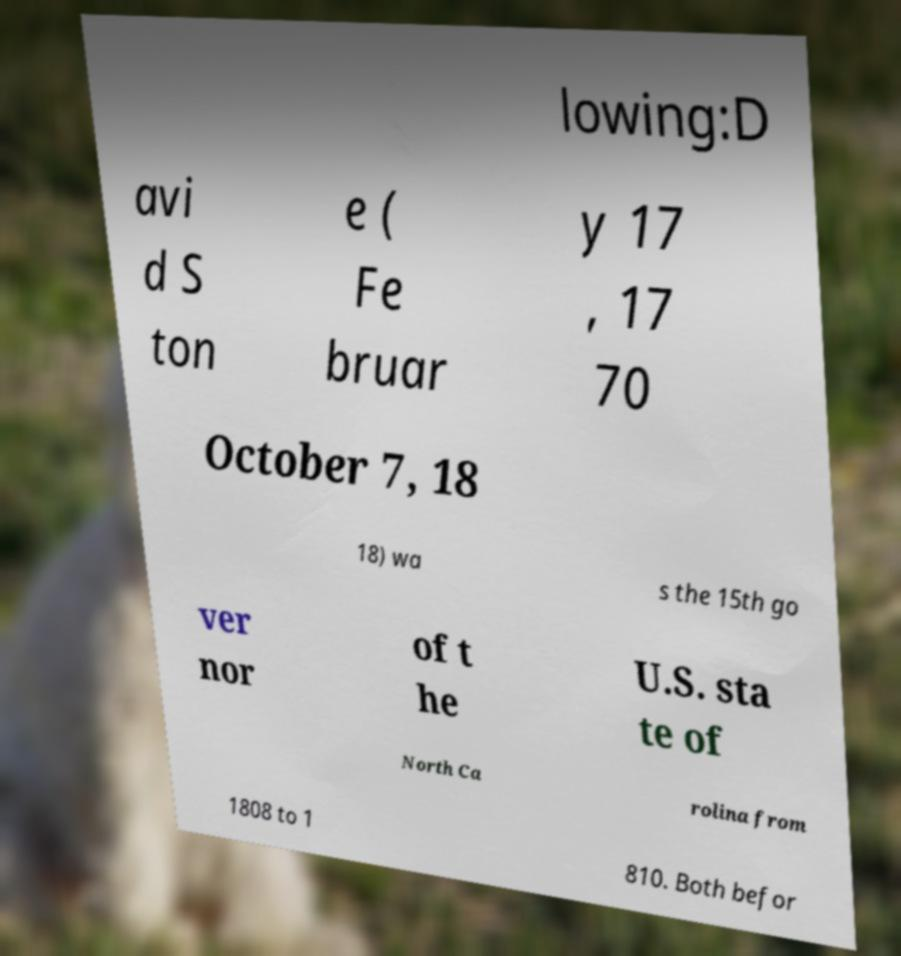What messages or text are displayed in this image? I need them in a readable, typed format. lowing:D avi d S ton e ( Fe bruar y 17 , 17 70 October 7, 18 18) wa s the 15th go ver nor of t he U.S. sta te of North Ca rolina from 1808 to 1 810. Both befor 